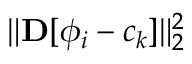<formula> <loc_0><loc_0><loc_500><loc_500>\| { D } [ \phi _ { i } - c _ { k } ] \| _ { 2 } ^ { 2 }</formula> 